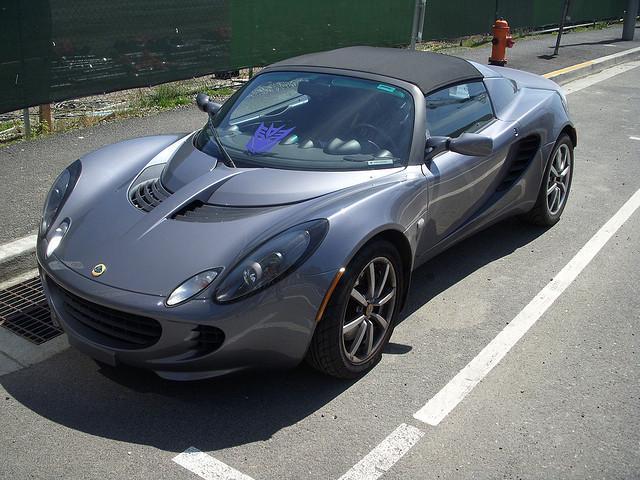How many mirrors can you see?
Give a very brief answer. 3. 